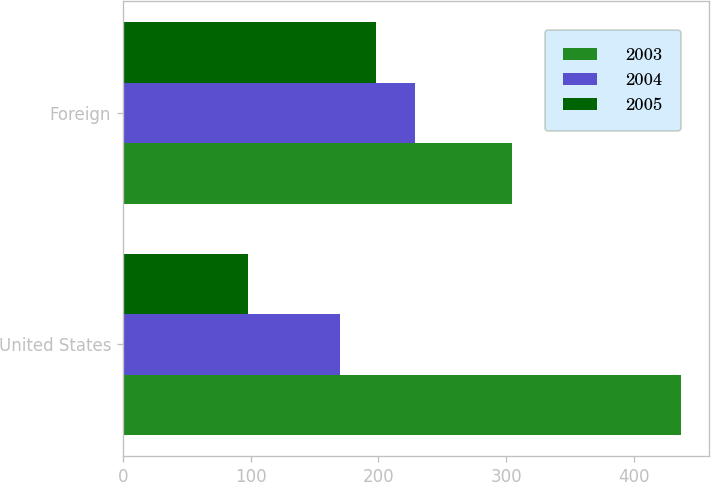<chart> <loc_0><loc_0><loc_500><loc_500><stacked_bar_chart><ecel><fcel>United States<fcel>Foreign<nl><fcel>2003<fcel>437<fcel>305<nl><fcel>2004<fcel>170<fcel>229<nl><fcel>2005<fcel>98<fcel>198<nl></chart> 